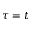<formula> <loc_0><loc_0><loc_500><loc_500>\tau = t</formula> 